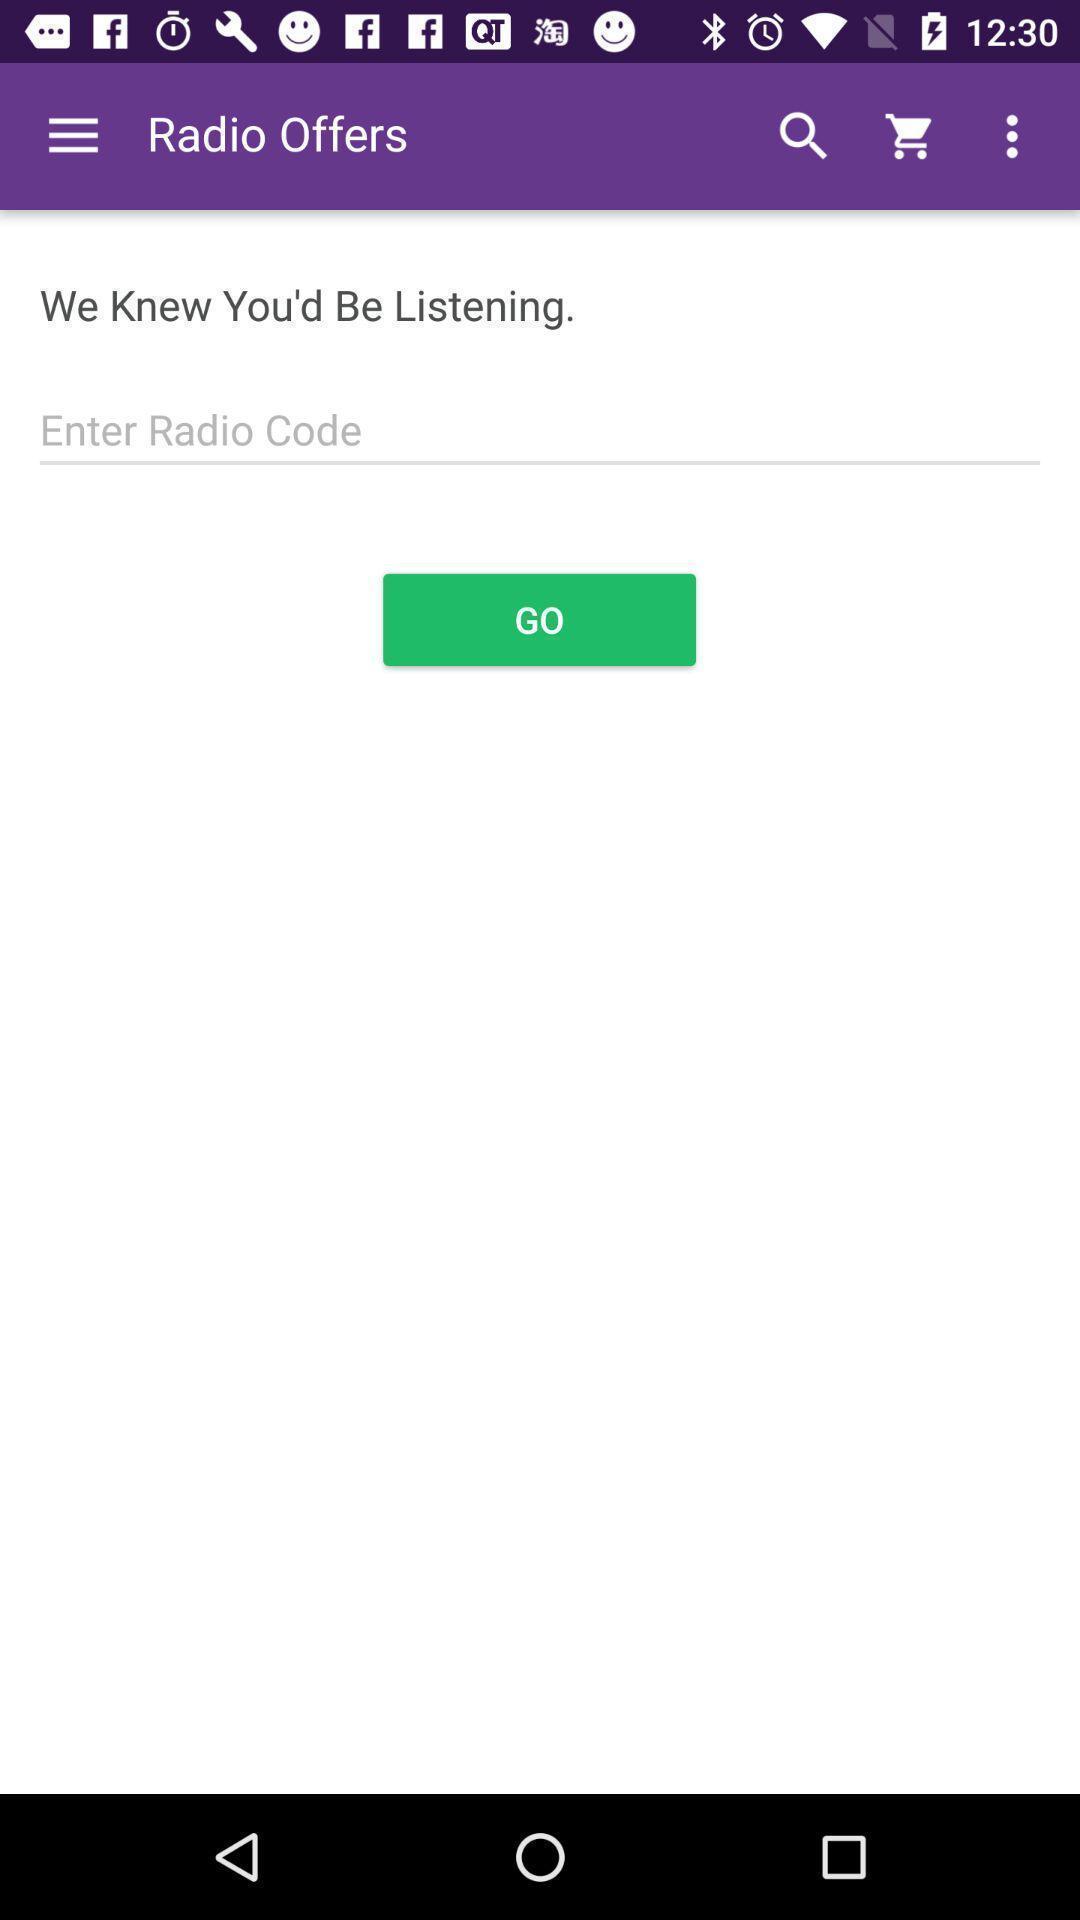Give me a narrative description of this picture. Page showing offers in gifts sending app. 